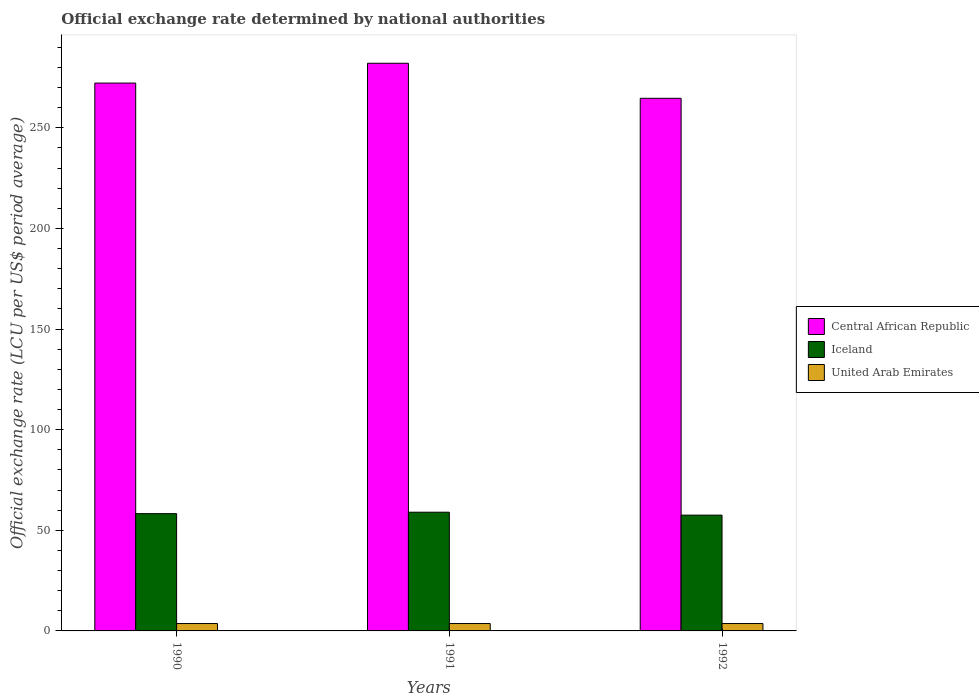How many groups of bars are there?
Your answer should be compact. 3. What is the label of the 1st group of bars from the left?
Provide a succinct answer. 1990. In how many cases, is the number of bars for a given year not equal to the number of legend labels?
Offer a terse response. 0. What is the official exchange rate in Central African Republic in 1991?
Provide a succinct answer. 282.11. Across all years, what is the maximum official exchange rate in United Arab Emirates?
Your answer should be compact. 3.67. Across all years, what is the minimum official exchange rate in Iceland?
Keep it short and to the point. 57.55. In which year was the official exchange rate in Central African Republic maximum?
Your response must be concise. 1991. What is the total official exchange rate in Iceland in the graph?
Offer a very short reply. 174.83. What is the difference between the official exchange rate in Iceland in 1991 and that in 1992?
Your answer should be compact. 1.45. What is the difference between the official exchange rate in United Arab Emirates in 1991 and the official exchange rate in Iceland in 1990?
Ensure brevity in your answer.  -54.61. What is the average official exchange rate in United Arab Emirates per year?
Offer a terse response. 3.67. In the year 1992, what is the difference between the official exchange rate in Iceland and official exchange rate in Central African Republic?
Make the answer very short. -207.15. In how many years, is the official exchange rate in Iceland greater than 110 LCU?
Keep it short and to the point. 0. What is the ratio of the official exchange rate in Iceland in 1991 to that in 1992?
Your response must be concise. 1.03. What is the difference between the highest and the second highest official exchange rate in United Arab Emirates?
Offer a very short reply. 0. What is the difference between the highest and the lowest official exchange rate in Iceland?
Your response must be concise. 1.45. In how many years, is the official exchange rate in Central African Republic greater than the average official exchange rate in Central African Republic taken over all years?
Make the answer very short. 1. Is the sum of the official exchange rate in Central African Republic in 1990 and 1991 greater than the maximum official exchange rate in Iceland across all years?
Offer a very short reply. Yes. What does the 3rd bar from the left in 1990 represents?
Make the answer very short. United Arab Emirates. What does the 3rd bar from the right in 1992 represents?
Keep it short and to the point. Central African Republic. How many years are there in the graph?
Provide a short and direct response. 3. What is the difference between two consecutive major ticks on the Y-axis?
Ensure brevity in your answer.  50. Are the values on the major ticks of Y-axis written in scientific E-notation?
Provide a short and direct response. No. Does the graph contain any zero values?
Keep it short and to the point. No. Does the graph contain grids?
Your answer should be compact. No. How many legend labels are there?
Your answer should be very brief. 3. What is the title of the graph?
Provide a short and direct response. Official exchange rate determined by national authorities. What is the label or title of the Y-axis?
Make the answer very short. Official exchange rate (LCU per US$ period average). What is the Official exchange rate (LCU per US$ period average) of Central African Republic in 1990?
Your answer should be compact. 272.26. What is the Official exchange rate (LCU per US$ period average) in Iceland in 1990?
Offer a terse response. 58.28. What is the Official exchange rate (LCU per US$ period average) in United Arab Emirates in 1990?
Provide a succinct answer. 3.67. What is the Official exchange rate (LCU per US$ period average) of Central African Republic in 1991?
Your response must be concise. 282.11. What is the Official exchange rate (LCU per US$ period average) in Iceland in 1991?
Ensure brevity in your answer.  59. What is the Official exchange rate (LCU per US$ period average) in United Arab Emirates in 1991?
Make the answer very short. 3.67. What is the Official exchange rate (LCU per US$ period average) in Central African Republic in 1992?
Your answer should be very brief. 264.69. What is the Official exchange rate (LCU per US$ period average) in Iceland in 1992?
Offer a very short reply. 57.55. What is the Official exchange rate (LCU per US$ period average) in United Arab Emirates in 1992?
Your response must be concise. 3.67. Across all years, what is the maximum Official exchange rate (LCU per US$ period average) of Central African Republic?
Offer a very short reply. 282.11. Across all years, what is the maximum Official exchange rate (LCU per US$ period average) in Iceland?
Your answer should be compact. 59. Across all years, what is the maximum Official exchange rate (LCU per US$ period average) of United Arab Emirates?
Provide a short and direct response. 3.67. Across all years, what is the minimum Official exchange rate (LCU per US$ period average) of Central African Republic?
Make the answer very short. 264.69. Across all years, what is the minimum Official exchange rate (LCU per US$ period average) in Iceland?
Give a very brief answer. 57.55. Across all years, what is the minimum Official exchange rate (LCU per US$ period average) of United Arab Emirates?
Your response must be concise. 3.67. What is the total Official exchange rate (LCU per US$ period average) of Central African Republic in the graph?
Make the answer very short. 819.06. What is the total Official exchange rate (LCU per US$ period average) in Iceland in the graph?
Keep it short and to the point. 174.83. What is the total Official exchange rate (LCU per US$ period average) in United Arab Emirates in the graph?
Your response must be concise. 11.01. What is the difference between the Official exchange rate (LCU per US$ period average) of Central African Republic in 1990 and that in 1991?
Give a very brief answer. -9.84. What is the difference between the Official exchange rate (LCU per US$ period average) of Iceland in 1990 and that in 1991?
Your answer should be compact. -0.71. What is the difference between the Official exchange rate (LCU per US$ period average) of United Arab Emirates in 1990 and that in 1991?
Your answer should be compact. 0. What is the difference between the Official exchange rate (LCU per US$ period average) in Central African Republic in 1990 and that in 1992?
Provide a succinct answer. 7.57. What is the difference between the Official exchange rate (LCU per US$ period average) of Iceland in 1990 and that in 1992?
Offer a very short reply. 0.74. What is the difference between the Official exchange rate (LCU per US$ period average) of Central African Republic in 1991 and that in 1992?
Provide a short and direct response. 17.42. What is the difference between the Official exchange rate (LCU per US$ period average) in Iceland in 1991 and that in 1992?
Your answer should be very brief. 1.45. What is the difference between the Official exchange rate (LCU per US$ period average) of United Arab Emirates in 1991 and that in 1992?
Provide a short and direct response. 0. What is the difference between the Official exchange rate (LCU per US$ period average) in Central African Republic in 1990 and the Official exchange rate (LCU per US$ period average) in Iceland in 1991?
Offer a very short reply. 213.27. What is the difference between the Official exchange rate (LCU per US$ period average) in Central African Republic in 1990 and the Official exchange rate (LCU per US$ period average) in United Arab Emirates in 1991?
Give a very brief answer. 268.59. What is the difference between the Official exchange rate (LCU per US$ period average) of Iceland in 1990 and the Official exchange rate (LCU per US$ period average) of United Arab Emirates in 1991?
Your answer should be compact. 54.61. What is the difference between the Official exchange rate (LCU per US$ period average) of Central African Republic in 1990 and the Official exchange rate (LCU per US$ period average) of Iceland in 1992?
Offer a very short reply. 214.72. What is the difference between the Official exchange rate (LCU per US$ period average) in Central African Republic in 1990 and the Official exchange rate (LCU per US$ period average) in United Arab Emirates in 1992?
Your answer should be very brief. 268.59. What is the difference between the Official exchange rate (LCU per US$ period average) in Iceland in 1990 and the Official exchange rate (LCU per US$ period average) in United Arab Emirates in 1992?
Offer a very short reply. 54.61. What is the difference between the Official exchange rate (LCU per US$ period average) of Central African Republic in 1991 and the Official exchange rate (LCU per US$ period average) of Iceland in 1992?
Offer a terse response. 224.56. What is the difference between the Official exchange rate (LCU per US$ period average) in Central African Republic in 1991 and the Official exchange rate (LCU per US$ period average) in United Arab Emirates in 1992?
Provide a short and direct response. 278.44. What is the difference between the Official exchange rate (LCU per US$ period average) of Iceland in 1991 and the Official exchange rate (LCU per US$ period average) of United Arab Emirates in 1992?
Offer a very short reply. 55.33. What is the average Official exchange rate (LCU per US$ period average) in Central African Republic per year?
Make the answer very short. 273.02. What is the average Official exchange rate (LCU per US$ period average) in Iceland per year?
Offer a terse response. 58.28. What is the average Official exchange rate (LCU per US$ period average) of United Arab Emirates per year?
Provide a succinct answer. 3.67. In the year 1990, what is the difference between the Official exchange rate (LCU per US$ period average) in Central African Republic and Official exchange rate (LCU per US$ period average) in Iceland?
Keep it short and to the point. 213.98. In the year 1990, what is the difference between the Official exchange rate (LCU per US$ period average) of Central African Republic and Official exchange rate (LCU per US$ period average) of United Arab Emirates?
Your answer should be very brief. 268.59. In the year 1990, what is the difference between the Official exchange rate (LCU per US$ period average) of Iceland and Official exchange rate (LCU per US$ period average) of United Arab Emirates?
Give a very brief answer. 54.61. In the year 1991, what is the difference between the Official exchange rate (LCU per US$ period average) of Central African Republic and Official exchange rate (LCU per US$ period average) of Iceland?
Keep it short and to the point. 223.11. In the year 1991, what is the difference between the Official exchange rate (LCU per US$ period average) of Central African Republic and Official exchange rate (LCU per US$ period average) of United Arab Emirates?
Provide a succinct answer. 278.44. In the year 1991, what is the difference between the Official exchange rate (LCU per US$ period average) of Iceland and Official exchange rate (LCU per US$ period average) of United Arab Emirates?
Your response must be concise. 55.33. In the year 1992, what is the difference between the Official exchange rate (LCU per US$ period average) in Central African Republic and Official exchange rate (LCU per US$ period average) in Iceland?
Your answer should be very brief. 207.15. In the year 1992, what is the difference between the Official exchange rate (LCU per US$ period average) of Central African Republic and Official exchange rate (LCU per US$ period average) of United Arab Emirates?
Keep it short and to the point. 261.02. In the year 1992, what is the difference between the Official exchange rate (LCU per US$ period average) in Iceland and Official exchange rate (LCU per US$ period average) in United Arab Emirates?
Give a very brief answer. 53.87. What is the ratio of the Official exchange rate (LCU per US$ period average) of Central African Republic in 1990 to that in 1991?
Your answer should be compact. 0.97. What is the ratio of the Official exchange rate (LCU per US$ period average) of Iceland in 1990 to that in 1991?
Your answer should be very brief. 0.99. What is the ratio of the Official exchange rate (LCU per US$ period average) in Central African Republic in 1990 to that in 1992?
Your answer should be very brief. 1.03. What is the ratio of the Official exchange rate (LCU per US$ period average) in Iceland in 1990 to that in 1992?
Make the answer very short. 1.01. What is the ratio of the Official exchange rate (LCU per US$ period average) in Central African Republic in 1991 to that in 1992?
Your answer should be very brief. 1.07. What is the ratio of the Official exchange rate (LCU per US$ period average) of Iceland in 1991 to that in 1992?
Provide a succinct answer. 1.03. What is the ratio of the Official exchange rate (LCU per US$ period average) in United Arab Emirates in 1991 to that in 1992?
Offer a terse response. 1. What is the difference between the highest and the second highest Official exchange rate (LCU per US$ period average) in Central African Republic?
Offer a very short reply. 9.84. What is the difference between the highest and the second highest Official exchange rate (LCU per US$ period average) of Iceland?
Make the answer very short. 0.71. What is the difference between the highest and the second highest Official exchange rate (LCU per US$ period average) in United Arab Emirates?
Your response must be concise. 0. What is the difference between the highest and the lowest Official exchange rate (LCU per US$ period average) of Central African Republic?
Your answer should be very brief. 17.42. What is the difference between the highest and the lowest Official exchange rate (LCU per US$ period average) of Iceland?
Provide a succinct answer. 1.45. 